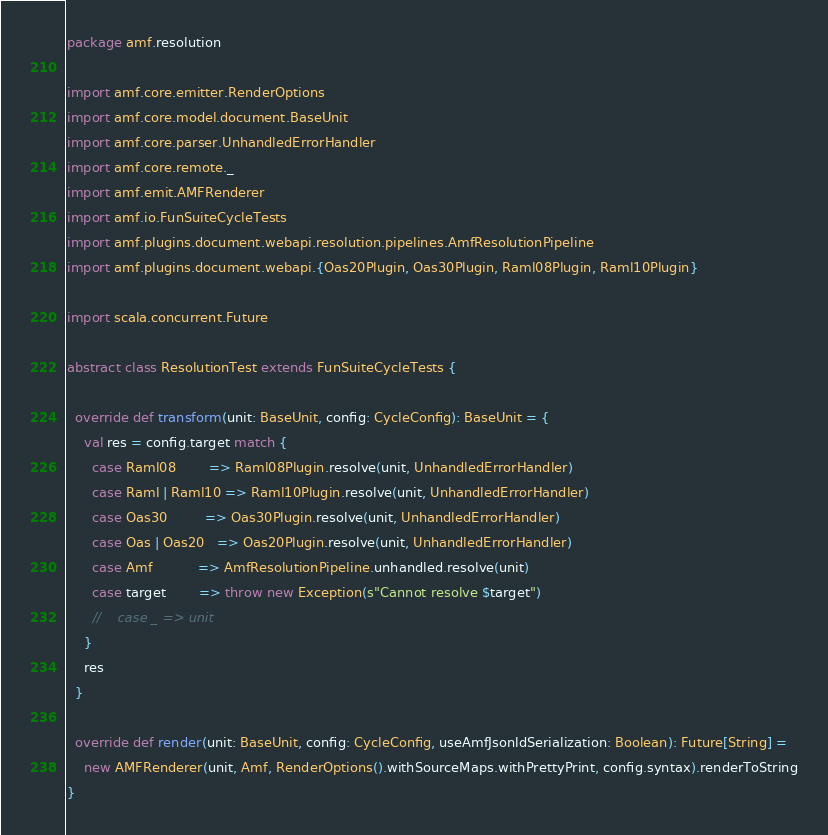Convert code to text. <code><loc_0><loc_0><loc_500><loc_500><_Scala_>package amf.resolution

import amf.core.emitter.RenderOptions
import amf.core.model.document.BaseUnit
import amf.core.parser.UnhandledErrorHandler
import amf.core.remote._
import amf.emit.AMFRenderer
import amf.io.FunSuiteCycleTests
import amf.plugins.document.webapi.resolution.pipelines.AmfResolutionPipeline
import amf.plugins.document.webapi.{Oas20Plugin, Oas30Plugin, Raml08Plugin, Raml10Plugin}

import scala.concurrent.Future

abstract class ResolutionTest extends FunSuiteCycleTests {

  override def transform(unit: BaseUnit, config: CycleConfig): BaseUnit = {
    val res = config.target match {
      case Raml08        => Raml08Plugin.resolve(unit, UnhandledErrorHandler)
      case Raml | Raml10 => Raml10Plugin.resolve(unit, UnhandledErrorHandler)
      case Oas30         => Oas30Plugin.resolve(unit, UnhandledErrorHandler)
      case Oas | Oas20   => Oas20Plugin.resolve(unit, UnhandledErrorHandler)
      case Amf           => AmfResolutionPipeline.unhandled.resolve(unit)
      case target        => throw new Exception(s"Cannot resolve $target")
      //    case _ => unit
    }
    res
  }

  override def render(unit: BaseUnit, config: CycleConfig, useAmfJsonldSerialization: Boolean): Future[String] =
    new AMFRenderer(unit, Amf, RenderOptions().withSourceMaps.withPrettyPrint, config.syntax).renderToString
}
</code> 